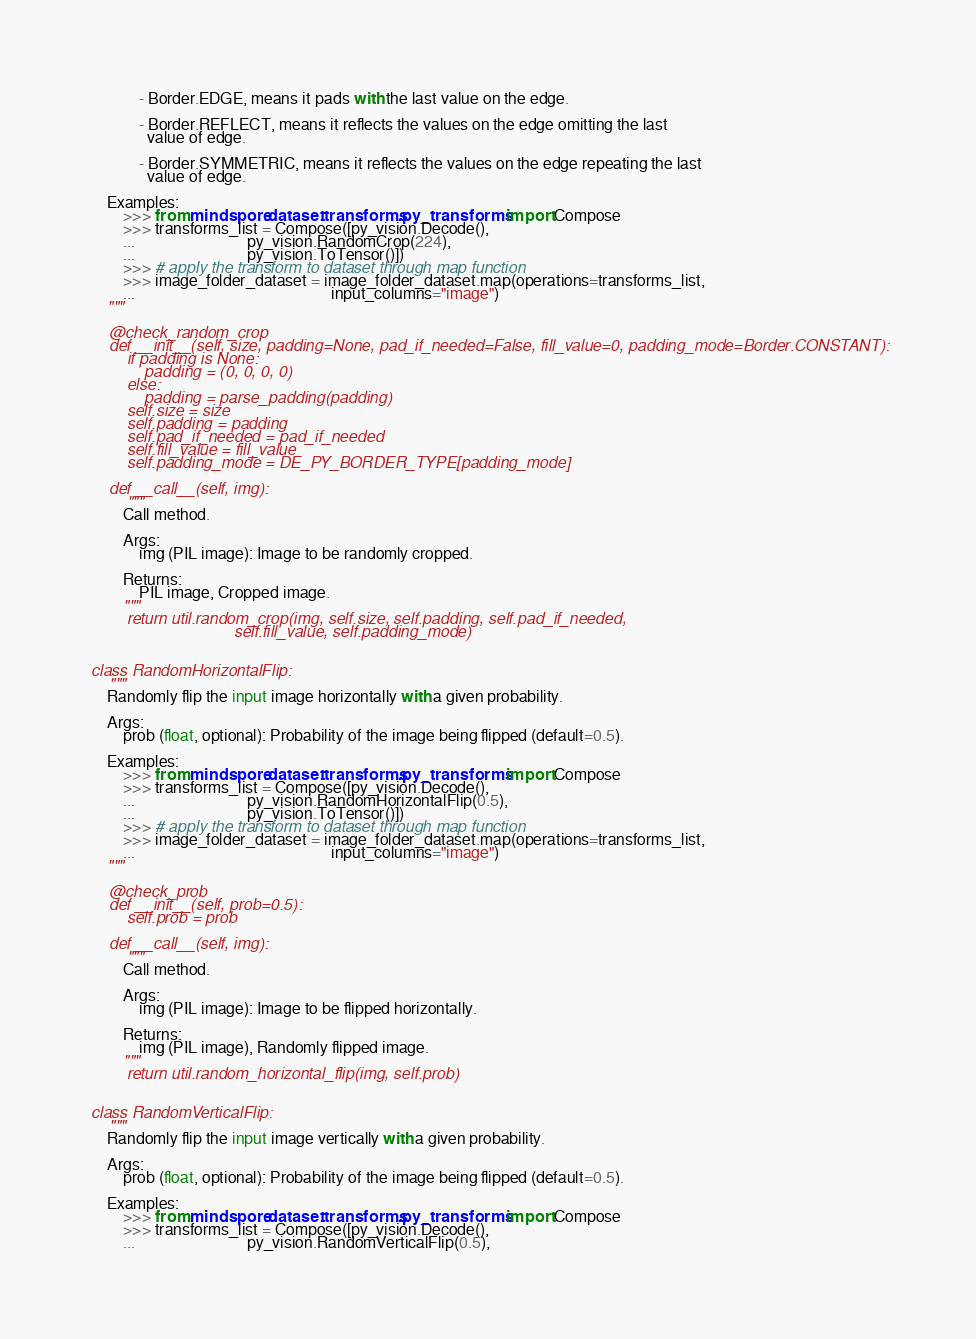<code> <loc_0><loc_0><loc_500><loc_500><_Python_>
            - Border.EDGE, means it pads with the last value on the edge.

            - Border.REFLECT, means it reflects the values on the edge omitting the last
              value of edge.

            - Border.SYMMETRIC, means it reflects the values on the edge repeating the last
              value of edge.

    Examples:
        >>> from mindspore.dataset.transforms.py_transforms import Compose
        >>> transforms_list = Compose([py_vision.Decode(),
        ...                            py_vision.RandomCrop(224),
        ...                            py_vision.ToTensor()])
        >>> # apply the transform to dataset through map function
        >>> image_folder_dataset = image_folder_dataset.map(operations=transforms_list,
        ...                                                 input_columns="image")
    """

    @check_random_crop
    def __init__(self, size, padding=None, pad_if_needed=False, fill_value=0, padding_mode=Border.CONSTANT):
        if padding is None:
            padding = (0, 0, 0, 0)
        else:
            padding = parse_padding(padding)
        self.size = size
        self.padding = padding
        self.pad_if_needed = pad_if_needed
        self.fill_value = fill_value
        self.padding_mode = DE_PY_BORDER_TYPE[padding_mode]

    def __call__(self, img):
        """
        Call method.

        Args:
            img (PIL image): Image to be randomly cropped.

        Returns:
            PIL image, Cropped image.
        """
        return util.random_crop(img, self.size, self.padding, self.pad_if_needed,
                                self.fill_value, self.padding_mode)


class RandomHorizontalFlip:
    """
    Randomly flip the input image horizontally with a given probability.

    Args:
        prob (float, optional): Probability of the image being flipped (default=0.5).

    Examples:
        >>> from mindspore.dataset.transforms.py_transforms import Compose
        >>> transforms_list = Compose([py_vision.Decode(),
        ...                            py_vision.RandomHorizontalFlip(0.5),
        ...                            py_vision.ToTensor()])
        >>> # apply the transform to dataset through map function
        >>> image_folder_dataset = image_folder_dataset.map(operations=transforms_list,
        ...                                                 input_columns="image")
    """

    @check_prob
    def __init__(self, prob=0.5):
        self.prob = prob

    def __call__(self, img):
        """
        Call method.

        Args:
            img (PIL image): Image to be flipped horizontally.

        Returns:
            img (PIL image), Randomly flipped image.
        """
        return util.random_horizontal_flip(img, self.prob)


class RandomVerticalFlip:
    """
    Randomly flip the input image vertically with a given probability.

    Args:
        prob (float, optional): Probability of the image being flipped (default=0.5).

    Examples:
        >>> from mindspore.dataset.transforms.py_transforms import Compose
        >>> transforms_list = Compose([py_vision.Decode(),
        ...                            py_vision.RandomVerticalFlip(0.5),</code> 